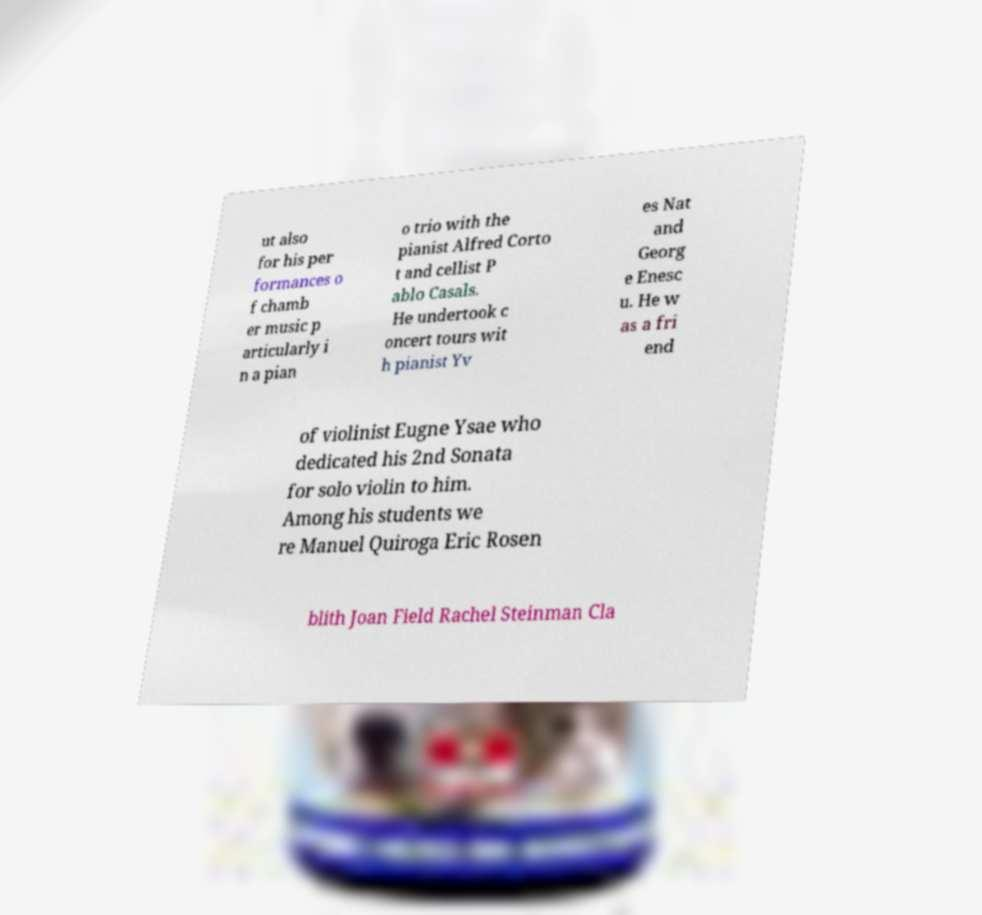Please identify and transcribe the text found in this image. ut also for his per formances o f chamb er music p articularly i n a pian o trio with the pianist Alfred Corto t and cellist P ablo Casals. He undertook c oncert tours wit h pianist Yv es Nat and Georg e Enesc u. He w as a fri end of violinist Eugne Ysae who dedicated his 2nd Sonata for solo violin to him. Among his students we re Manuel Quiroga Eric Rosen blith Joan Field Rachel Steinman Cla 